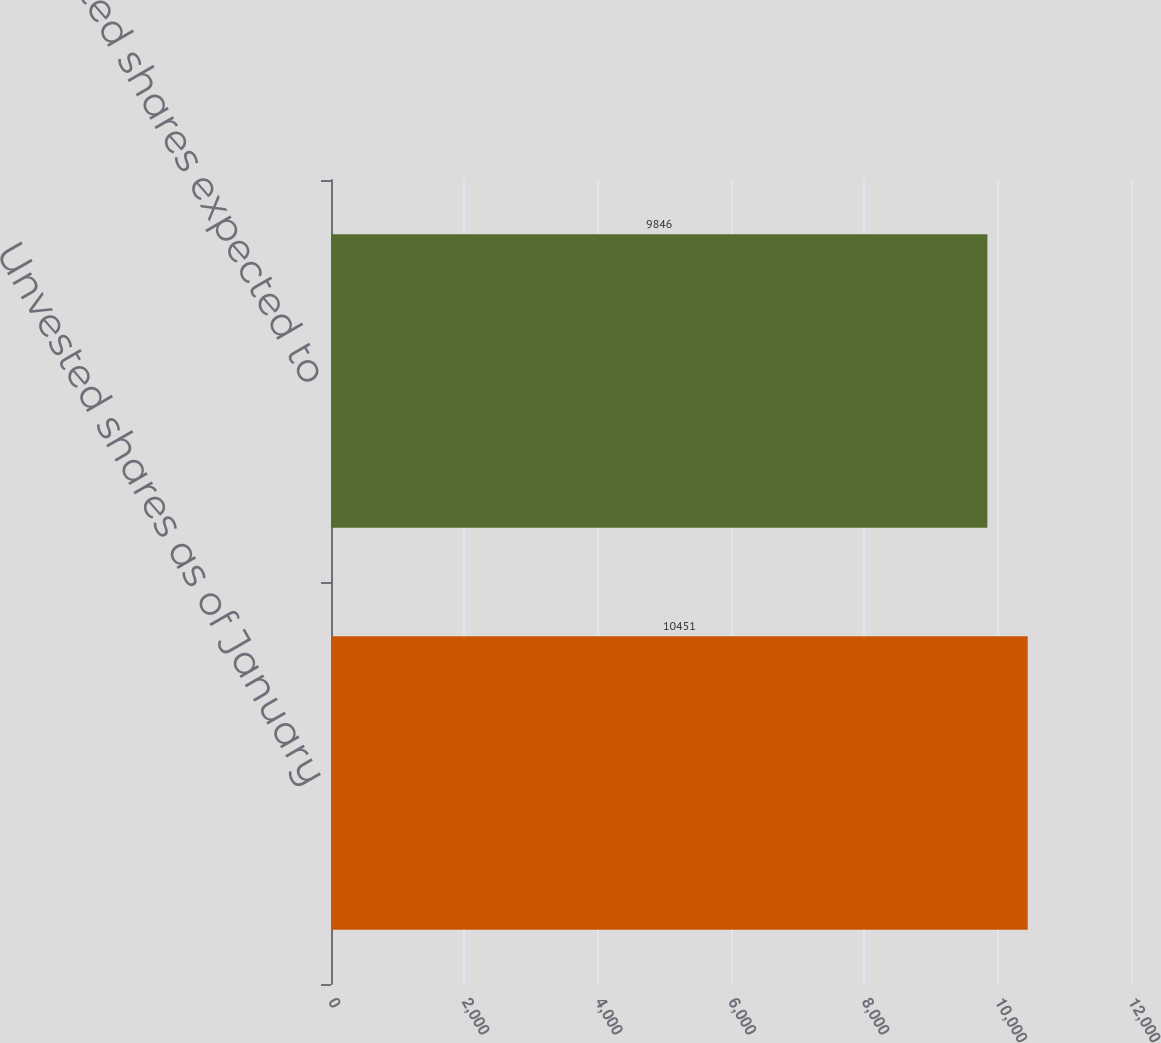Convert chart to OTSL. <chart><loc_0><loc_0><loc_500><loc_500><bar_chart><fcel>Unvested shares as of January<fcel>Unvested shares expected to<nl><fcel>10451<fcel>9846<nl></chart> 